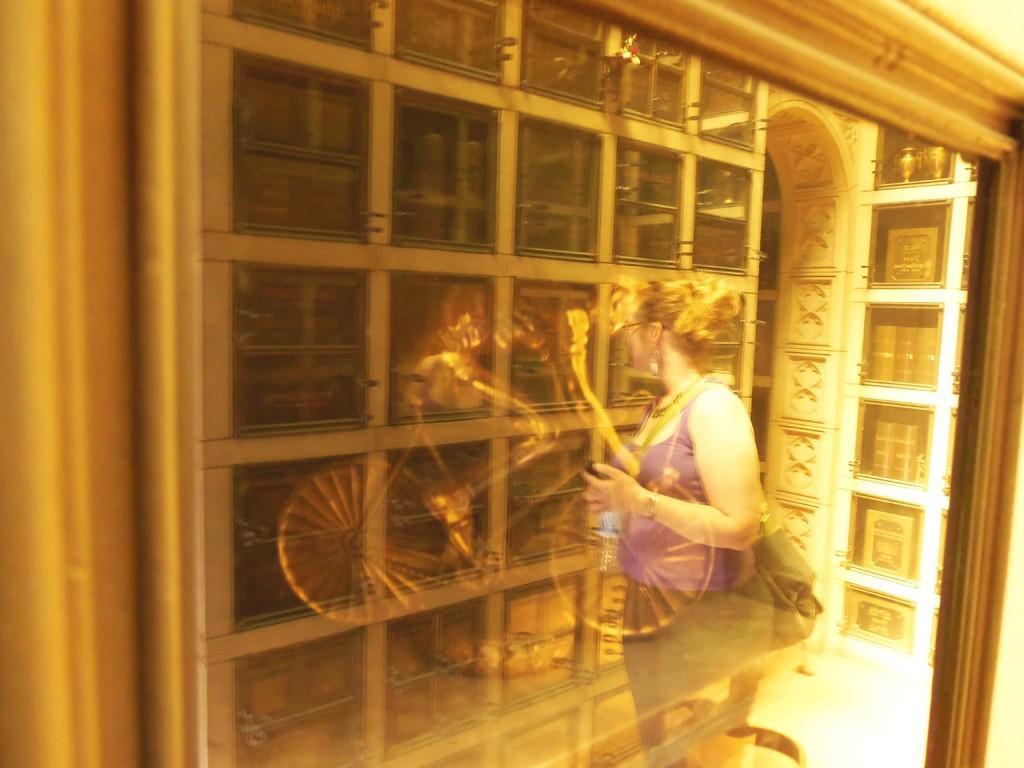Can you describe this image briefly? The picture consists of a frame, in the frame there is a sculpture of a person riding bicycle. The picture consists of the reflection of a woman standing. 